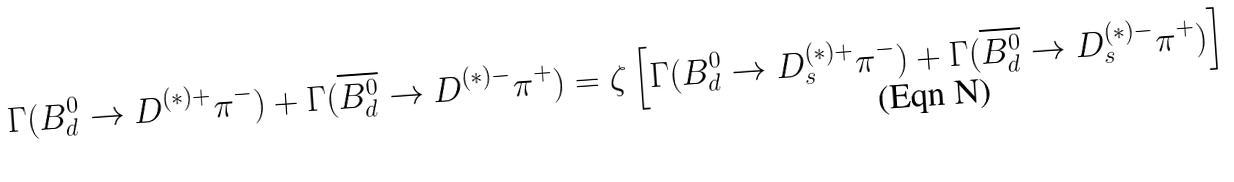Convert formula to latex. <formula><loc_0><loc_0><loc_500><loc_500>\Gamma ( B ^ { 0 } _ { d } \to D ^ { ( \ast ) + } \pi ^ { - } ) + \Gamma ( \overline { B ^ { 0 } _ { d } } \to D ^ { ( \ast ) - } \pi ^ { + } ) = \zeta \left [ \Gamma ( B ^ { 0 } _ { d } \to D _ { s } ^ { ( \ast ) + } \pi ^ { - } ) + \Gamma ( \overline { B ^ { 0 } _ { d } } \to D _ { s } ^ { ( \ast ) - } \pi ^ { + } ) \right ]</formula> 